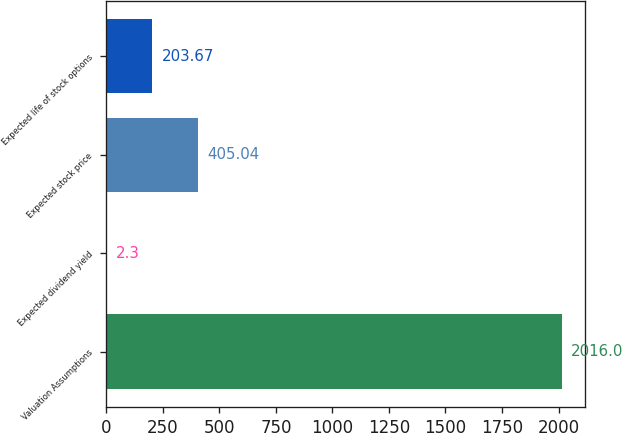<chart> <loc_0><loc_0><loc_500><loc_500><bar_chart><fcel>Valuation Assumptions<fcel>Expected dividend yield<fcel>Expected stock price<fcel>Expected life of stock options<nl><fcel>2016<fcel>2.3<fcel>405.04<fcel>203.67<nl></chart> 